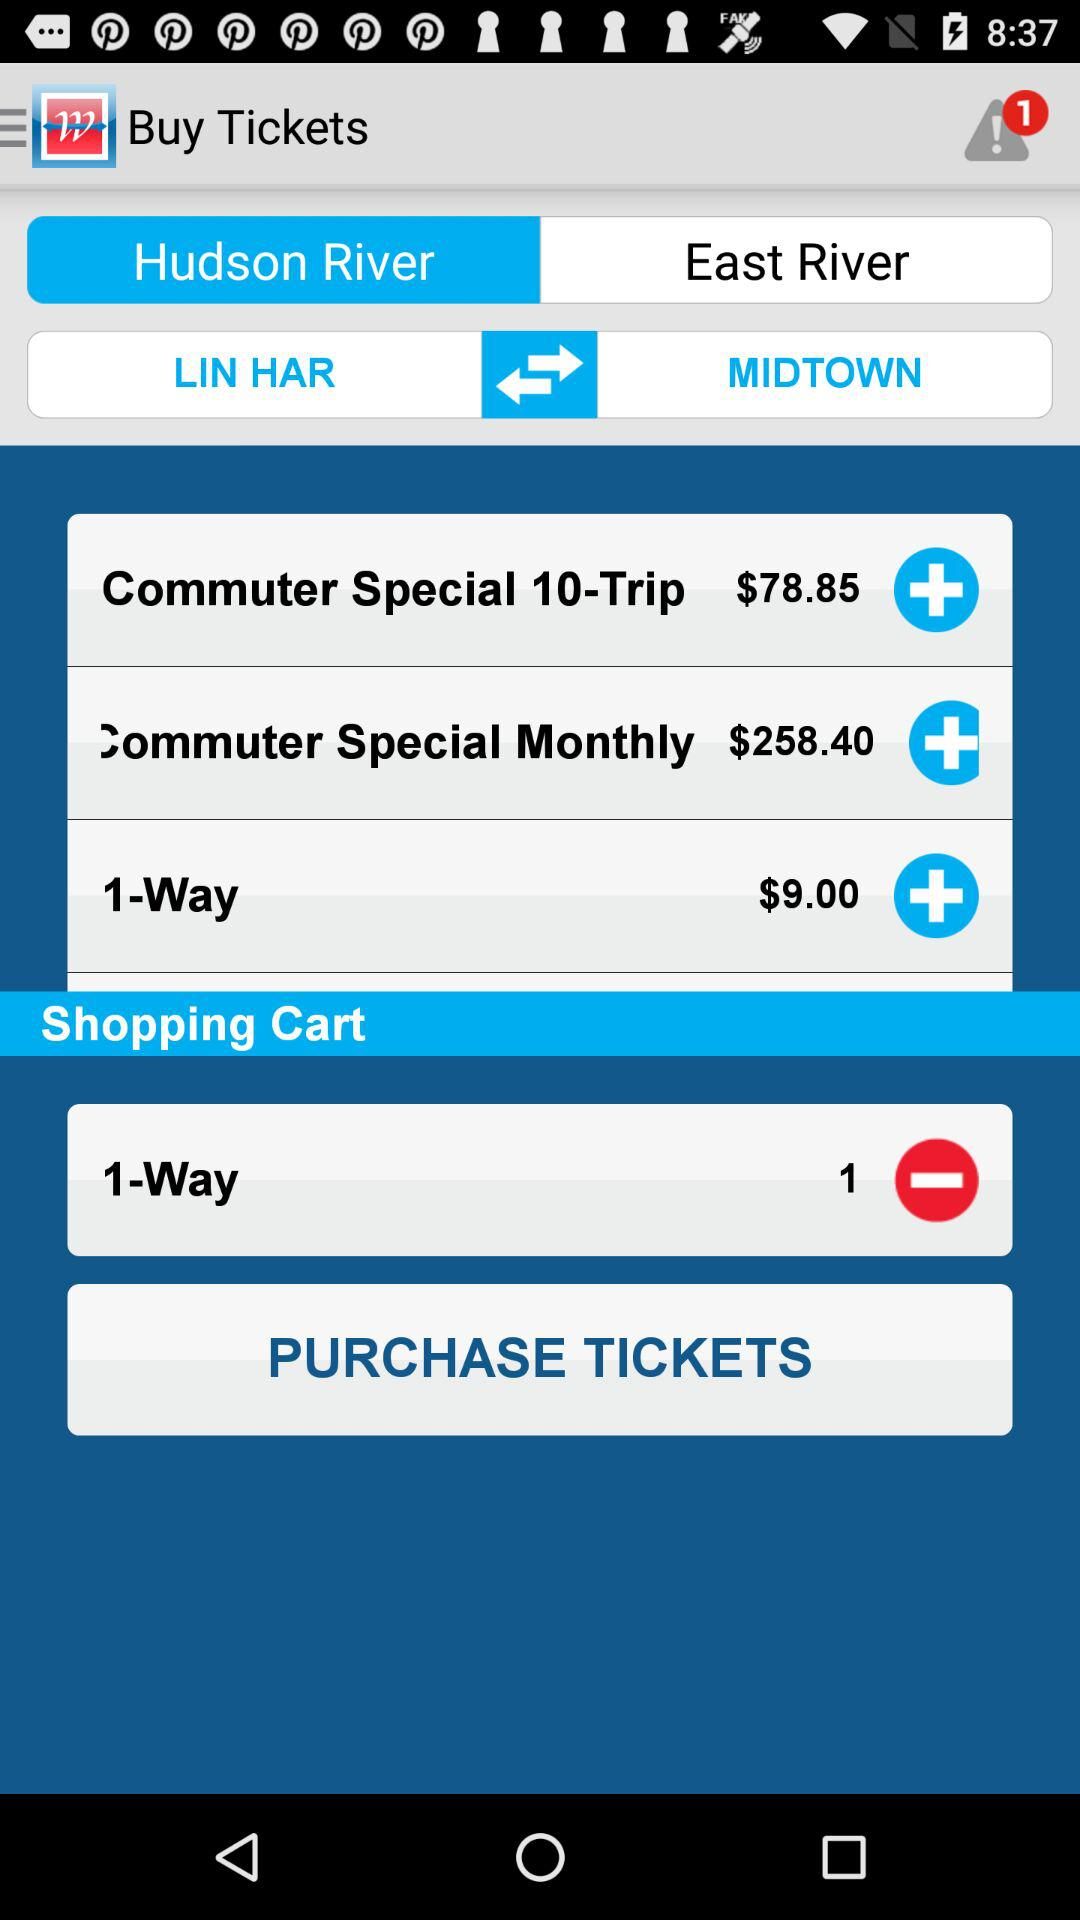How many more dollars is the Commuter Special Monthly than the Commuter Special 10-Trip?
Answer the question using a single word or phrase. 179.55 